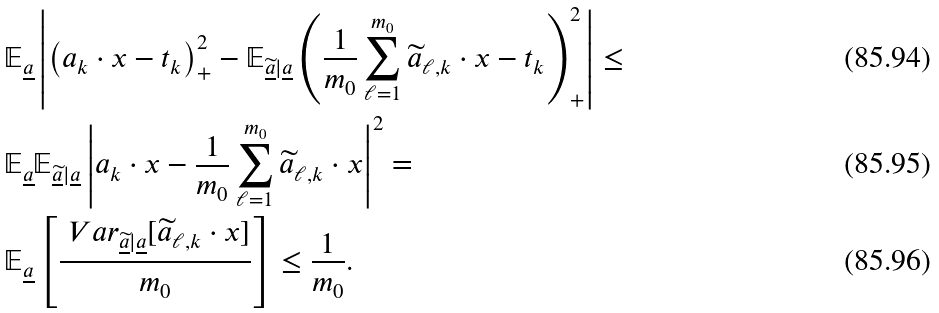Convert formula to latex. <formula><loc_0><loc_0><loc_500><loc_500>& \mathbb { E } _ { \underline { a } } \left | \left ( a _ { k } \cdot x - t _ { k } \right ) ^ { 2 } _ { + } - \mathbb { E } _ { \underline { \widetilde { a } } | \underline { a } } \left ( \frac { 1 } { m _ { 0 } } \sum _ { \ell = 1 } ^ { m _ { 0 } } \widetilde { a } _ { \ell , k } \cdot x - t _ { k } \right ) ^ { 2 } _ { + } \right | \leq \\ & \mathbb { E } _ { \underline { a } } \mathbb { E } _ { \underline { \widetilde { a } } | \underline { a } } \left | a _ { k } \cdot x - \frac { 1 } { m _ { 0 } } \sum _ { \ell = 1 } ^ { m _ { 0 } } { \widetilde { a } } _ { \ell , k } \cdot x \right | ^ { 2 } = \\ & \mathbb { E } _ { \underline { a } } \left [ \frac { \ V a r _ { \underline { \widetilde { a } } | \underline { a } } [ \widetilde { a } _ { \ell , k } \cdot x ] } { m _ { 0 } } \right ] \leq \frac { 1 } { m _ { 0 } } .</formula> 